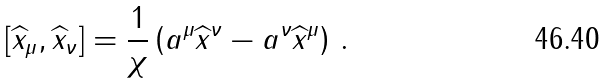Convert formula to latex. <formula><loc_0><loc_0><loc_500><loc_500>\left [ \widehat { x } _ { \mu } , \widehat { x } _ { \nu } \right ] = \frac { 1 } { \chi } \left ( a ^ { \mu } \widehat { x } ^ { \nu } - a ^ { \nu } \widehat { x } ^ { \mu } \right ) \, .</formula> 